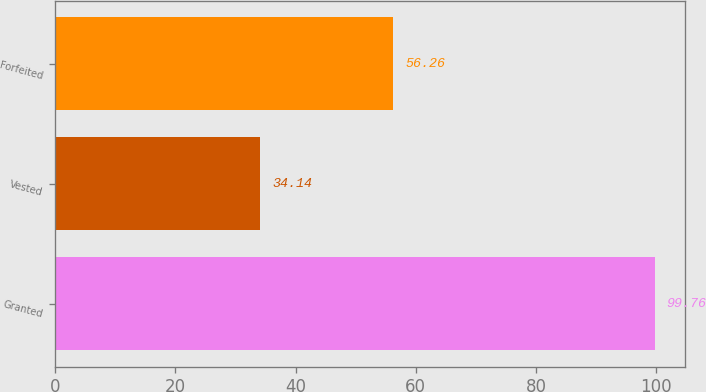<chart> <loc_0><loc_0><loc_500><loc_500><bar_chart><fcel>Granted<fcel>Vested<fcel>Forfeited<nl><fcel>99.76<fcel>34.14<fcel>56.26<nl></chart> 